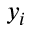<formula> <loc_0><loc_0><loc_500><loc_500>y _ { i }</formula> 